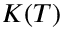<formula> <loc_0><loc_0><loc_500><loc_500>K ( T )</formula> 